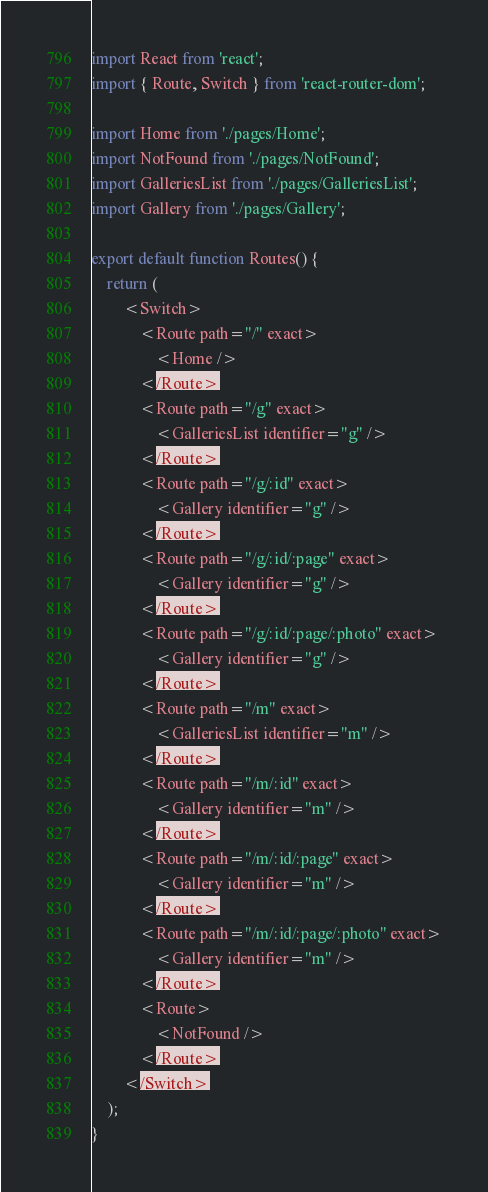Convert code to text. <code><loc_0><loc_0><loc_500><loc_500><_JavaScript_>import React from 'react';
import { Route, Switch } from 'react-router-dom';

import Home from './pages/Home';
import NotFound from './pages/NotFound';
import GalleriesList from './pages/GalleriesList';
import Gallery from './pages/Gallery';

export default function Routes() {
    return (
        <Switch>
            <Route path="/" exact>
                <Home />
            </Route>
            <Route path="/g" exact>
                <GalleriesList identifier="g" />
            </Route>
            <Route path="/g/:id" exact>
                <Gallery identifier="g" />
            </Route>
            <Route path="/g/:id/:page" exact>
                <Gallery identifier="g" />
            </Route>
            <Route path="/g/:id/:page/:photo" exact>
                <Gallery identifier="g" />
            </Route>
            <Route path="/m" exact>
                <GalleriesList identifier="m" />
            </Route>
            <Route path="/m/:id" exact>
                <Gallery identifier="m" />
            </Route>
            <Route path="/m/:id/:page" exact>
                <Gallery identifier="m" />
            </Route>
            <Route path="/m/:id/:page/:photo" exact>
                <Gallery identifier="m" />
            </Route>
            <Route>
                <NotFound />
            </Route>
        </Switch>
    );
}
</code> 